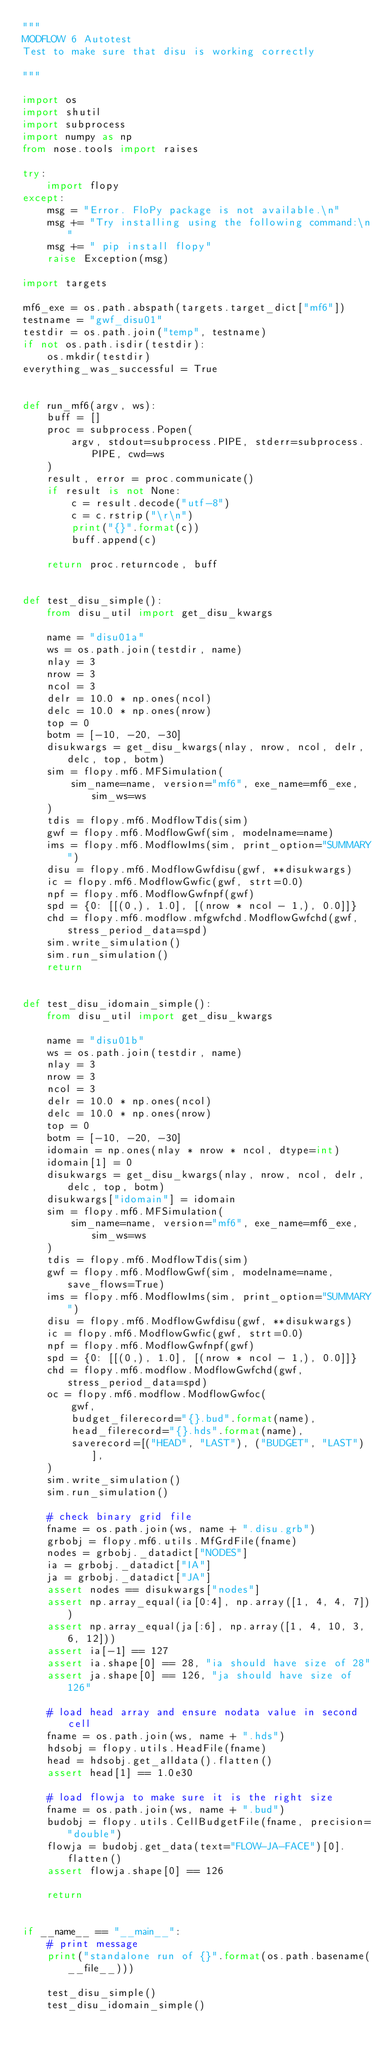Convert code to text. <code><loc_0><loc_0><loc_500><loc_500><_Python_>"""
MODFLOW 6 Autotest
Test to make sure that disu is working correctly

"""

import os
import shutil
import subprocess
import numpy as np
from nose.tools import raises

try:
    import flopy
except:
    msg = "Error. FloPy package is not available.\n"
    msg += "Try installing using the following command:\n"
    msg += " pip install flopy"
    raise Exception(msg)

import targets

mf6_exe = os.path.abspath(targets.target_dict["mf6"])
testname = "gwf_disu01"
testdir = os.path.join("temp", testname)
if not os.path.isdir(testdir):
    os.mkdir(testdir)
everything_was_successful = True


def run_mf6(argv, ws):
    buff = []
    proc = subprocess.Popen(
        argv, stdout=subprocess.PIPE, stderr=subprocess.PIPE, cwd=ws
    )
    result, error = proc.communicate()
    if result is not None:
        c = result.decode("utf-8")
        c = c.rstrip("\r\n")
        print("{}".format(c))
        buff.append(c)

    return proc.returncode, buff


def test_disu_simple():
    from disu_util import get_disu_kwargs

    name = "disu01a"
    ws = os.path.join(testdir, name)
    nlay = 3
    nrow = 3
    ncol = 3
    delr = 10.0 * np.ones(ncol)
    delc = 10.0 * np.ones(nrow)
    top = 0
    botm = [-10, -20, -30]
    disukwargs = get_disu_kwargs(nlay, nrow, ncol, delr, delc, top, botm)
    sim = flopy.mf6.MFSimulation(
        sim_name=name, version="mf6", exe_name=mf6_exe, sim_ws=ws
    )
    tdis = flopy.mf6.ModflowTdis(sim)
    gwf = flopy.mf6.ModflowGwf(sim, modelname=name)
    ims = flopy.mf6.ModflowIms(sim, print_option="SUMMARY")
    disu = flopy.mf6.ModflowGwfdisu(gwf, **disukwargs)
    ic = flopy.mf6.ModflowGwfic(gwf, strt=0.0)
    npf = flopy.mf6.ModflowGwfnpf(gwf)
    spd = {0: [[(0,), 1.0], [(nrow * ncol - 1,), 0.0]]}
    chd = flopy.mf6.modflow.mfgwfchd.ModflowGwfchd(gwf, stress_period_data=spd)
    sim.write_simulation()
    sim.run_simulation()
    return


def test_disu_idomain_simple():
    from disu_util import get_disu_kwargs

    name = "disu01b"
    ws = os.path.join(testdir, name)
    nlay = 3
    nrow = 3
    ncol = 3
    delr = 10.0 * np.ones(ncol)
    delc = 10.0 * np.ones(nrow)
    top = 0
    botm = [-10, -20, -30]
    idomain = np.ones(nlay * nrow * ncol, dtype=int)
    idomain[1] = 0
    disukwargs = get_disu_kwargs(nlay, nrow, ncol, delr, delc, top, botm)
    disukwargs["idomain"] = idomain
    sim = flopy.mf6.MFSimulation(
        sim_name=name, version="mf6", exe_name=mf6_exe, sim_ws=ws
    )
    tdis = flopy.mf6.ModflowTdis(sim)
    gwf = flopy.mf6.ModflowGwf(sim, modelname=name, save_flows=True)
    ims = flopy.mf6.ModflowIms(sim, print_option="SUMMARY")
    disu = flopy.mf6.ModflowGwfdisu(gwf, **disukwargs)
    ic = flopy.mf6.ModflowGwfic(gwf, strt=0.0)
    npf = flopy.mf6.ModflowGwfnpf(gwf)
    spd = {0: [[(0,), 1.0], [(nrow * ncol - 1,), 0.0]]}
    chd = flopy.mf6.modflow.ModflowGwfchd(gwf, stress_period_data=spd)
    oc = flopy.mf6.modflow.ModflowGwfoc(
        gwf,
        budget_filerecord="{}.bud".format(name),
        head_filerecord="{}.hds".format(name),
        saverecord=[("HEAD", "LAST"), ("BUDGET", "LAST")],
    )
    sim.write_simulation()
    sim.run_simulation()

    # check binary grid file
    fname = os.path.join(ws, name + ".disu.grb")
    grbobj = flopy.mf6.utils.MfGrdFile(fname)
    nodes = grbobj._datadict["NODES"]
    ia = grbobj._datadict["IA"]
    ja = grbobj._datadict["JA"]
    assert nodes == disukwargs["nodes"]
    assert np.array_equal(ia[0:4], np.array([1, 4, 4, 7]))
    assert np.array_equal(ja[:6], np.array([1, 4, 10, 3, 6, 12]))
    assert ia[-1] == 127
    assert ia.shape[0] == 28, "ia should have size of 28"
    assert ja.shape[0] == 126, "ja should have size of 126"

    # load head array and ensure nodata value in second cell
    fname = os.path.join(ws, name + ".hds")
    hdsobj = flopy.utils.HeadFile(fname)
    head = hdsobj.get_alldata().flatten()
    assert head[1] == 1.0e30

    # load flowja to make sure it is the right size
    fname = os.path.join(ws, name + ".bud")
    budobj = flopy.utils.CellBudgetFile(fname, precision="double")
    flowja = budobj.get_data(text="FLOW-JA-FACE")[0].flatten()
    assert flowja.shape[0] == 126

    return


if __name__ == "__main__":
    # print message
    print("standalone run of {}".format(os.path.basename(__file__)))

    test_disu_simple()
    test_disu_idomain_simple()
</code> 